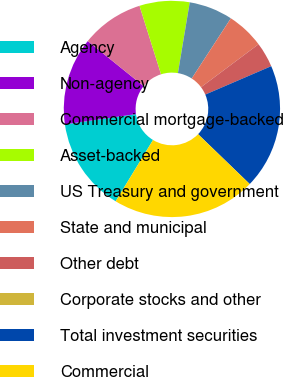<chart> <loc_0><loc_0><loc_500><loc_500><pie_chart><fcel>Agency<fcel>Non-agency<fcel>Commercial mortgage-backed<fcel>Asset-backed<fcel>US Treasury and government<fcel>State and municipal<fcel>Other debt<fcel>Corporate stocks and other<fcel>Total investment securities<fcel>Commercial<nl><fcel>14.02%<fcel>13.08%<fcel>9.35%<fcel>7.48%<fcel>6.54%<fcel>5.61%<fcel>3.74%<fcel>0.0%<fcel>18.69%<fcel>21.49%<nl></chart> 